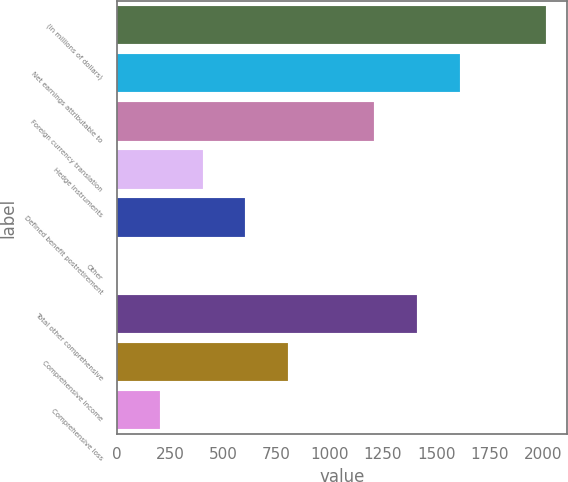<chart> <loc_0><loc_0><loc_500><loc_500><bar_chart><fcel>(in millions of dollars)<fcel>Net earnings attributable to<fcel>Foreign currency translation<fcel>Hedge instruments<fcel>Defined benefit postretirement<fcel>Other<fcel>Total other comprehensive<fcel>Comprehensive income<fcel>Comprehensive loss<nl><fcel>2014<fcel>1611.26<fcel>1208.52<fcel>403.04<fcel>604.41<fcel>0.3<fcel>1409.89<fcel>805.78<fcel>201.67<nl></chart> 